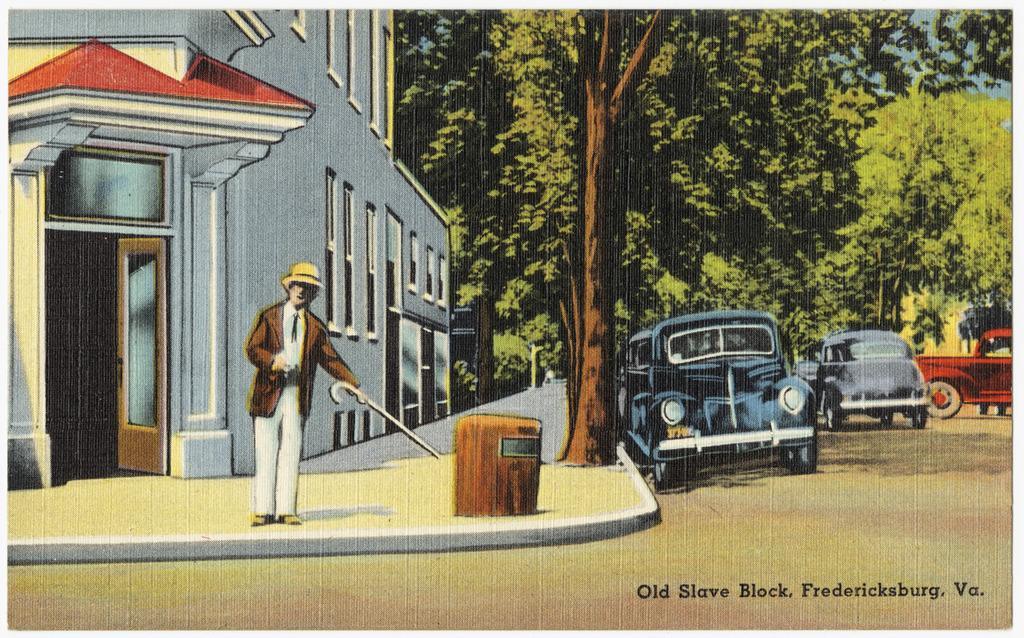Can you describe this image briefly? In this picture there is a person wearing brown suit is standing and holding a stick in his hand and there is a building behind him and there are trees and vehicles in the right corner. 